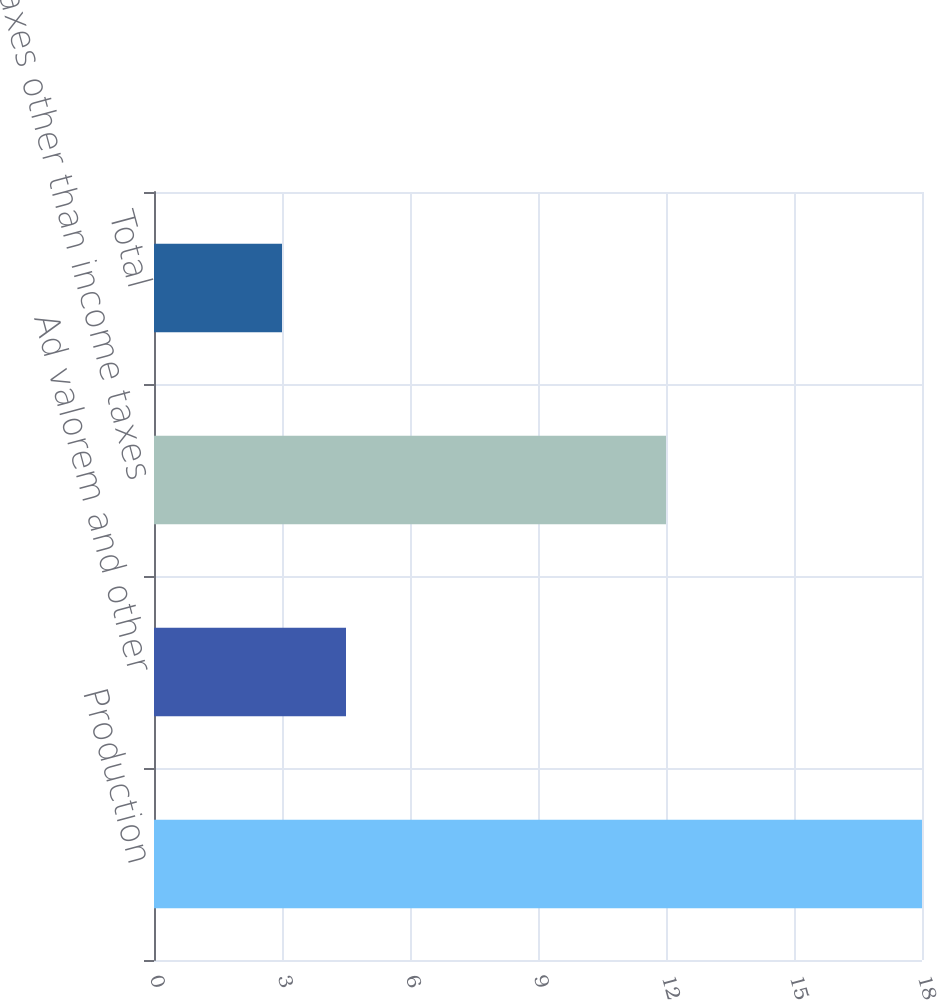Convert chart. <chart><loc_0><loc_0><loc_500><loc_500><bar_chart><fcel>Production<fcel>Ad valorem and other<fcel>Taxes other than income taxes<fcel>Total<nl><fcel>18<fcel>4.5<fcel>12<fcel>3<nl></chart> 